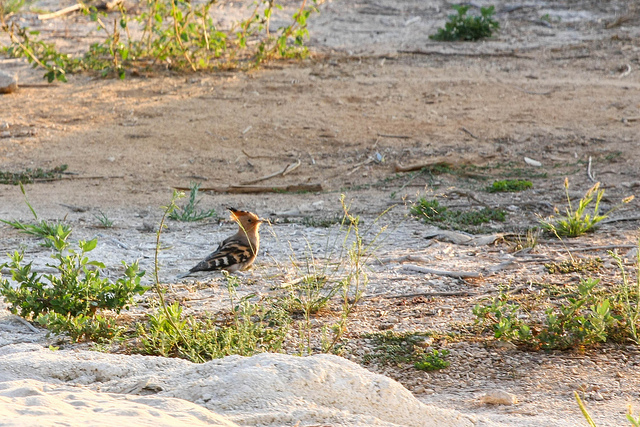<image>What type of bird is this? It is ambiguous to tell what type of bird this is. It could be a variety of birds such as a pheasant, woodpecker, finch, hummingbird, duck, or kingfisher. What type of bird is in the picture? I am not sure what type of bird is in the picture. It can be a variety of types such as cockatoo, sand bird, hoopoe, partridge, pelican, cockadoo or woodpecker. What type of bird is this? I am not sure what type of bird this is. It can be seen as 'pheasant', 'woodpecker', 'finch', 'hummingbird', 'duck' or 'kingfisher'. What type of bird is in the picture? I don't know what type of bird is in the picture. It could be a cockatoo, sand bird, hoopoe, partridge, pelican, cockadoo, woodpecker, or brown bird. 